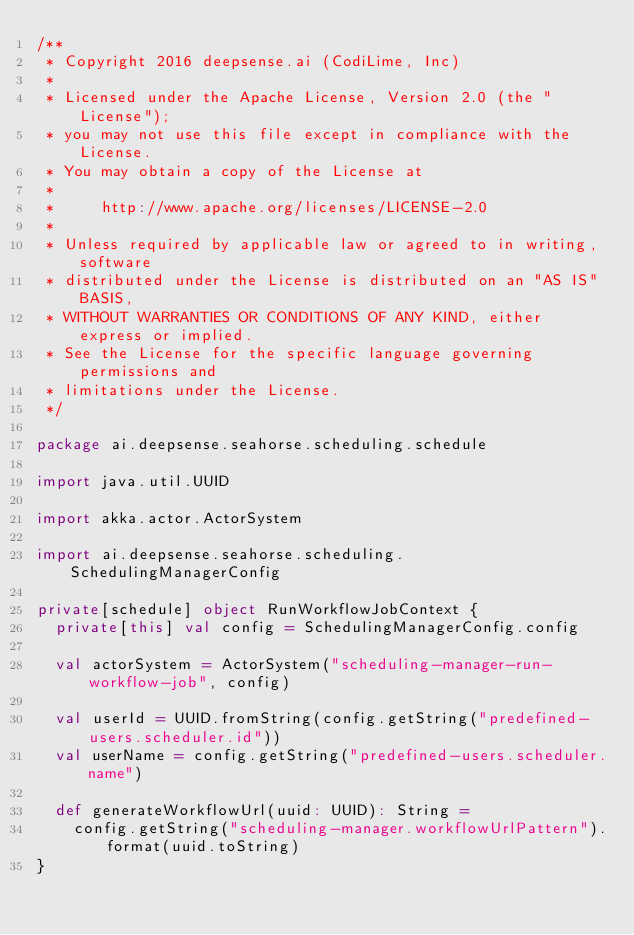<code> <loc_0><loc_0><loc_500><loc_500><_Scala_>/**
 * Copyright 2016 deepsense.ai (CodiLime, Inc)
 *
 * Licensed under the Apache License, Version 2.0 (the "License");
 * you may not use this file except in compliance with the License.
 * You may obtain a copy of the License at
 *
 *     http://www.apache.org/licenses/LICENSE-2.0
 *
 * Unless required by applicable law or agreed to in writing, software
 * distributed under the License is distributed on an "AS IS" BASIS,
 * WITHOUT WARRANTIES OR CONDITIONS OF ANY KIND, either express or implied.
 * See the License for the specific language governing permissions and
 * limitations under the License.
 */

package ai.deepsense.seahorse.scheduling.schedule

import java.util.UUID

import akka.actor.ActorSystem

import ai.deepsense.seahorse.scheduling.SchedulingManagerConfig

private[schedule] object RunWorkflowJobContext {
  private[this] val config = SchedulingManagerConfig.config

  val actorSystem = ActorSystem("scheduling-manager-run-workflow-job", config)

  val userId = UUID.fromString(config.getString("predefined-users.scheduler.id"))
  val userName = config.getString("predefined-users.scheduler.name")

  def generateWorkflowUrl(uuid: UUID): String =
    config.getString("scheduling-manager.workflowUrlPattern").format(uuid.toString)
}
</code> 